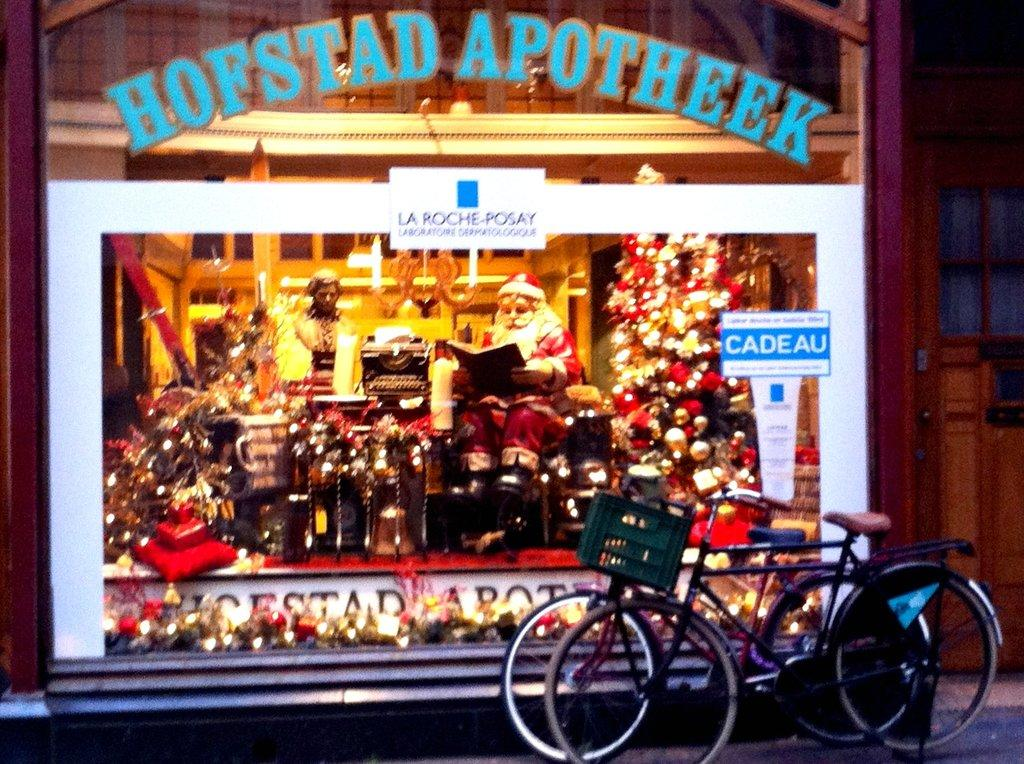What type of vehicles are on the right side of the image? There are two bicycles on the right side of the image. What object in the image can be used for personal grooming or checking one's appearance? There is a mirror in the image. What is written on the mirror in the image? There is text written on the mirror. How much milk is being burned in the image? There is no milk or burning depicted in the image. What memory is being triggered by the text on the mirror in the image? The image does not provide any information about memories or their triggers. 